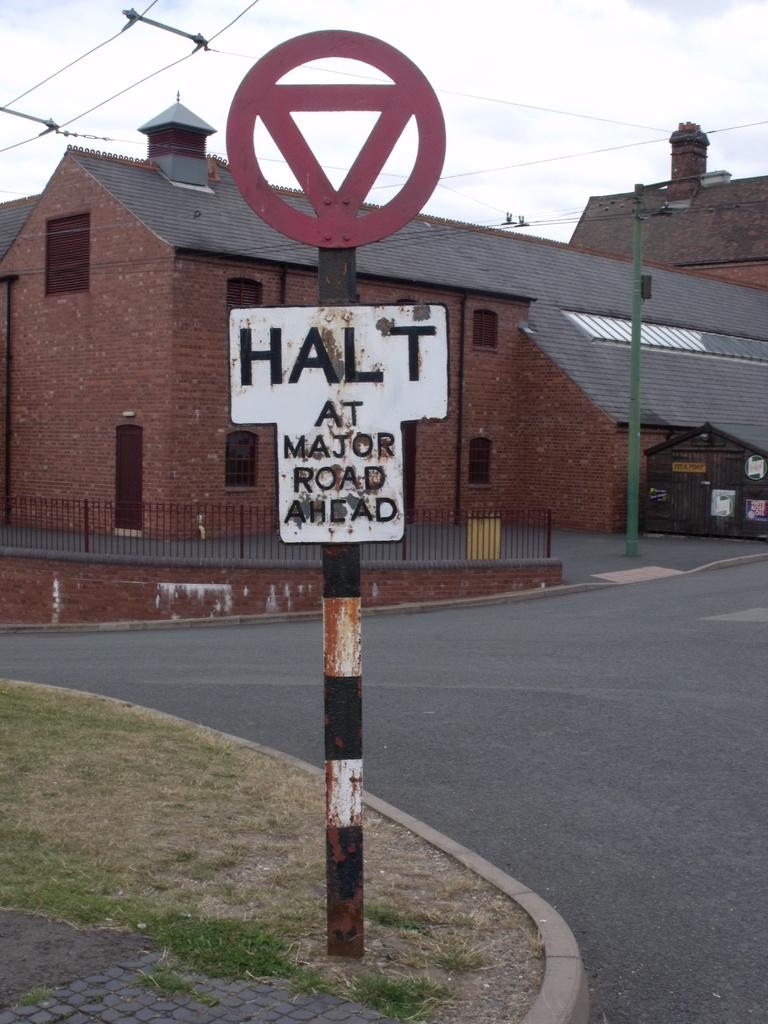<image>
Share a concise interpretation of the image provided. A white sign says Halt At Major Road Ahead is in front of a brick building. 